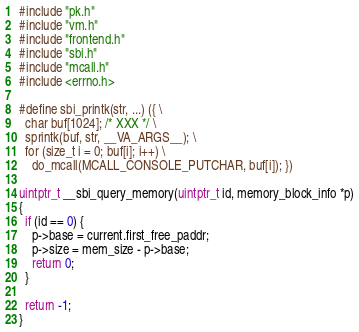<code> <loc_0><loc_0><loc_500><loc_500><_C_>#include "pk.h"
#include "vm.h"
#include "frontend.h"
#include "sbi.h"
#include "mcall.h"
#include <errno.h>

#define sbi_printk(str, ...) ({ \
  char buf[1024]; /* XXX */ \
  sprintk(buf, str, __VA_ARGS__); \
  for (size_t i = 0; buf[i]; i++) \
    do_mcall(MCALL_CONSOLE_PUTCHAR, buf[i]); })

uintptr_t __sbi_query_memory(uintptr_t id, memory_block_info *p)
{
  if (id == 0) {
    p->base = current.first_free_paddr;
    p->size = mem_size - p->base;
    return 0;
  }

  return -1;
}
</code> 